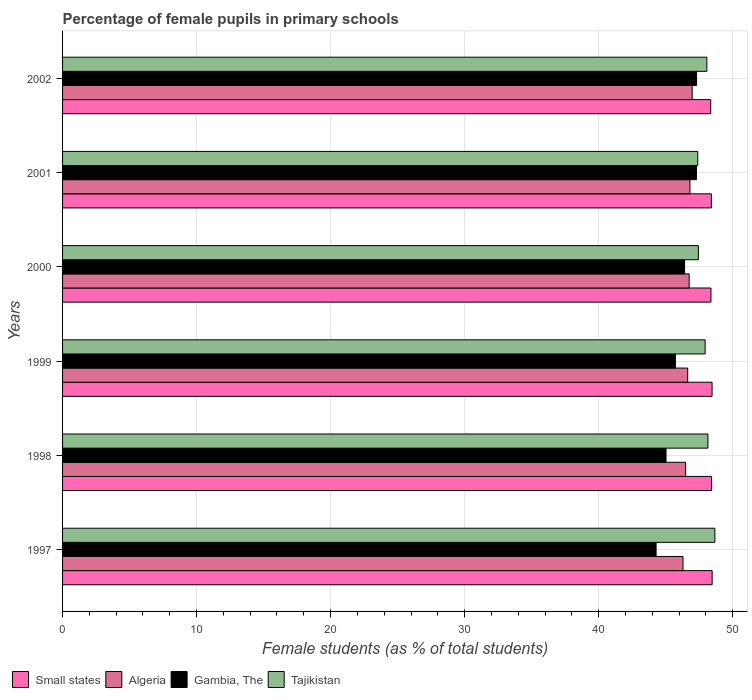Are the number of bars on each tick of the Y-axis equal?
Offer a very short reply. Yes. What is the label of the 1st group of bars from the top?
Your answer should be very brief. 2002. In how many cases, is the number of bars for a given year not equal to the number of legend labels?
Your answer should be very brief. 0. What is the percentage of female pupils in primary schools in Gambia, The in 2002?
Offer a terse response. 47.31. Across all years, what is the maximum percentage of female pupils in primary schools in Small states?
Make the answer very short. 48.47. Across all years, what is the minimum percentage of female pupils in primary schools in Small states?
Offer a terse response. 48.37. What is the total percentage of female pupils in primary schools in Gambia, The in the graph?
Your response must be concise. 276.08. What is the difference between the percentage of female pupils in primary schools in Small states in 1998 and that in 2001?
Offer a terse response. 0.02. What is the difference between the percentage of female pupils in primary schools in Tajikistan in 2000 and the percentage of female pupils in primary schools in Algeria in 1997?
Keep it short and to the point. 1.15. What is the average percentage of female pupils in primary schools in Gambia, The per year?
Your answer should be compact. 46.01. In the year 1998, what is the difference between the percentage of female pupils in primary schools in Small states and percentage of female pupils in primary schools in Tajikistan?
Your response must be concise. 0.27. What is the ratio of the percentage of female pupils in primary schools in Algeria in 1999 to that in 2000?
Offer a very short reply. 1. Is the percentage of female pupils in primary schools in Tajikistan in 1998 less than that in 1999?
Your answer should be compact. No. What is the difference between the highest and the second highest percentage of female pupils in primary schools in Small states?
Your answer should be very brief. 0.01. What is the difference between the highest and the lowest percentage of female pupils in primary schools in Tajikistan?
Provide a short and direct response. 1.28. What does the 2nd bar from the top in 1998 represents?
Give a very brief answer. Gambia, The. What does the 2nd bar from the bottom in 2000 represents?
Provide a succinct answer. Algeria. Is it the case that in every year, the sum of the percentage of female pupils in primary schools in Algeria and percentage of female pupils in primary schools in Tajikistan is greater than the percentage of female pupils in primary schools in Small states?
Offer a very short reply. Yes. Are all the bars in the graph horizontal?
Provide a succinct answer. Yes. How many years are there in the graph?
Offer a very short reply. 6. Are the values on the major ticks of X-axis written in scientific E-notation?
Provide a succinct answer. No. How many legend labels are there?
Provide a succinct answer. 4. How are the legend labels stacked?
Provide a succinct answer. Horizontal. What is the title of the graph?
Ensure brevity in your answer.  Percentage of female pupils in primary schools. What is the label or title of the X-axis?
Provide a short and direct response. Female students (as % of total students). What is the label or title of the Y-axis?
Your answer should be very brief. Years. What is the Female students (as % of total students) in Small states in 1997?
Offer a terse response. 48.47. What is the Female students (as % of total students) in Algeria in 1997?
Make the answer very short. 46.3. What is the Female students (as % of total students) of Gambia, The in 1997?
Offer a terse response. 44.29. What is the Female students (as % of total students) in Tajikistan in 1997?
Your answer should be compact. 48.68. What is the Female students (as % of total students) of Small states in 1998?
Provide a short and direct response. 48.43. What is the Female students (as % of total students) in Algeria in 1998?
Offer a very short reply. 46.49. What is the Female students (as % of total students) of Gambia, The in 1998?
Provide a short and direct response. 45.03. What is the Female students (as % of total students) of Tajikistan in 1998?
Offer a very short reply. 48.16. What is the Female students (as % of total students) of Small states in 1999?
Offer a very short reply. 48.47. What is the Female students (as % of total students) in Algeria in 1999?
Offer a very short reply. 46.65. What is the Female students (as % of total students) of Gambia, The in 1999?
Make the answer very short. 45.73. What is the Female students (as % of total students) of Tajikistan in 1999?
Give a very brief answer. 47.95. What is the Female students (as % of total students) of Small states in 2000?
Your answer should be compact. 48.38. What is the Female students (as % of total students) of Algeria in 2000?
Your answer should be compact. 46.76. What is the Female students (as % of total students) in Gambia, The in 2000?
Provide a succinct answer. 46.42. What is the Female students (as % of total students) of Tajikistan in 2000?
Your answer should be very brief. 47.44. What is the Female students (as % of total students) in Small states in 2001?
Your response must be concise. 48.41. What is the Female students (as % of total students) of Algeria in 2001?
Provide a short and direct response. 46.82. What is the Female students (as % of total students) in Gambia, The in 2001?
Your answer should be compact. 47.3. What is the Female students (as % of total students) of Tajikistan in 2001?
Provide a short and direct response. 47.4. What is the Female students (as % of total students) of Small states in 2002?
Provide a short and direct response. 48.37. What is the Female students (as % of total students) of Algeria in 2002?
Give a very brief answer. 46.98. What is the Female students (as % of total students) in Gambia, The in 2002?
Make the answer very short. 47.31. What is the Female students (as % of total students) in Tajikistan in 2002?
Make the answer very short. 48.08. Across all years, what is the maximum Female students (as % of total students) in Small states?
Provide a short and direct response. 48.47. Across all years, what is the maximum Female students (as % of total students) in Algeria?
Make the answer very short. 46.98. Across all years, what is the maximum Female students (as % of total students) in Gambia, The?
Ensure brevity in your answer.  47.31. Across all years, what is the maximum Female students (as % of total students) of Tajikistan?
Your answer should be compact. 48.68. Across all years, what is the minimum Female students (as % of total students) of Small states?
Keep it short and to the point. 48.37. Across all years, what is the minimum Female students (as % of total students) of Algeria?
Offer a very short reply. 46.3. Across all years, what is the minimum Female students (as % of total students) of Gambia, The?
Provide a succinct answer. 44.29. Across all years, what is the minimum Female students (as % of total students) in Tajikistan?
Ensure brevity in your answer.  47.4. What is the total Female students (as % of total students) in Small states in the graph?
Provide a short and direct response. 290.53. What is the total Female students (as % of total students) in Algeria in the graph?
Keep it short and to the point. 279.99. What is the total Female students (as % of total students) in Gambia, The in the graph?
Give a very brief answer. 276.08. What is the total Female students (as % of total students) in Tajikistan in the graph?
Make the answer very short. 287.7. What is the difference between the Female students (as % of total students) in Algeria in 1997 and that in 1998?
Provide a short and direct response. -0.2. What is the difference between the Female students (as % of total students) in Gambia, The in 1997 and that in 1998?
Your answer should be compact. -0.74. What is the difference between the Female students (as % of total students) of Tajikistan in 1997 and that in 1998?
Provide a short and direct response. 0.52. What is the difference between the Female students (as % of total students) of Small states in 1997 and that in 1999?
Your answer should be compact. 0.01. What is the difference between the Female students (as % of total students) in Algeria in 1997 and that in 1999?
Offer a terse response. -0.35. What is the difference between the Female students (as % of total students) in Gambia, The in 1997 and that in 1999?
Offer a very short reply. -1.44. What is the difference between the Female students (as % of total students) of Tajikistan in 1997 and that in 1999?
Your answer should be compact. 0.73. What is the difference between the Female students (as % of total students) of Small states in 1997 and that in 2000?
Keep it short and to the point. 0.09. What is the difference between the Female students (as % of total students) of Algeria in 1997 and that in 2000?
Offer a terse response. -0.46. What is the difference between the Female students (as % of total students) in Gambia, The in 1997 and that in 2000?
Give a very brief answer. -2.13. What is the difference between the Female students (as % of total students) in Tajikistan in 1997 and that in 2000?
Provide a succinct answer. 1.23. What is the difference between the Female students (as % of total students) in Small states in 1997 and that in 2001?
Give a very brief answer. 0.06. What is the difference between the Female students (as % of total students) in Algeria in 1997 and that in 2001?
Your answer should be compact. -0.52. What is the difference between the Female students (as % of total students) of Gambia, The in 1997 and that in 2001?
Provide a succinct answer. -3.01. What is the difference between the Female students (as % of total students) in Tajikistan in 1997 and that in 2001?
Provide a succinct answer. 1.28. What is the difference between the Female students (as % of total students) of Small states in 1997 and that in 2002?
Offer a very short reply. 0.11. What is the difference between the Female students (as % of total students) in Algeria in 1997 and that in 2002?
Offer a terse response. -0.69. What is the difference between the Female students (as % of total students) in Gambia, The in 1997 and that in 2002?
Offer a terse response. -3.02. What is the difference between the Female students (as % of total students) in Tajikistan in 1997 and that in 2002?
Keep it short and to the point. 0.6. What is the difference between the Female students (as % of total students) of Small states in 1998 and that in 1999?
Give a very brief answer. -0.03. What is the difference between the Female students (as % of total students) in Algeria in 1998 and that in 1999?
Your answer should be compact. -0.15. What is the difference between the Female students (as % of total students) of Gambia, The in 1998 and that in 1999?
Provide a succinct answer. -0.7. What is the difference between the Female students (as % of total students) of Tajikistan in 1998 and that in 1999?
Your answer should be very brief. 0.21. What is the difference between the Female students (as % of total students) of Small states in 1998 and that in 2000?
Make the answer very short. 0.05. What is the difference between the Female students (as % of total students) in Algeria in 1998 and that in 2000?
Your answer should be very brief. -0.27. What is the difference between the Female students (as % of total students) in Gambia, The in 1998 and that in 2000?
Offer a very short reply. -1.39. What is the difference between the Female students (as % of total students) of Tajikistan in 1998 and that in 2000?
Offer a very short reply. 0.72. What is the difference between the Female students (as % of total students) in Small states in 1998 and that in 2001?
Offer a terse response. 0.02. What is the difference between the Female students (as % of total students) of Algeria in 1998 and that in 2001?
Your answer should be very brief. -0.32. What is the difference between the Female students (as % of total students) in Gambia, The in 1998 and that in 2001?
Your response must be concise. -2.27. What is the difference between the Female students (as % of total students) of Tajikistan in 1998 and that in 2001?
Give a very brief answer. 0.76. What is the difference between the Female students (as % of total students) in Small states in 1998 and that in 2002?
Provide a succinct answer. 0.07. What is the difference between the Female students (as % of total students) in Algeria in 1998 and that in 2002?
Give a very brief answer. -0.49. What is the difference between the Female students (as % of total students) of Gambia, The in 1998 and that in 2002?
Provide a succinct answer. -2.28. What is the difference between the Female students (as % of total students) of Tajikistan in 1998 and that in 2002?
Your answer should be compact. 0.08. What is the difference between the Female students (as % of total students) of Small states in 1999 and that in 2000?
Offer a very short reply. 0.08. What is the difference between the Female students (as % of total students) in Algeria in 1999 and that in 2000?
Offer a terse response. -0.11. What is the difference between the Female students (as % of total students) in Gambia, The in 1999 and that in 2000?
Make the answer very short. -0.69. What is the difference between the Female students (as % of total students) in Tajikistan in 1999 and that in 2000?
Your response must be concise. 0.51. What is the difference between the Female students (as % of total students) in Small states in 1999 and that in 2001?
Your answer should be compact. 0.05. What is the difference between the Female students (as % of total students) in Algeria in 1999 and that in 2001?
Provide a short and direct response. -0.17. What is the difference between the Female students (as % of total students) of Gambia, The in 1999 and that in 2001?
Your answer should be very brief. -1.57. What is the difference between the Female students (as % of total students) of Tajikistan in 1999 and that in 2001?
Your response must be concise. 0.55. What is the difference between the Female students (as % of total students) of Small states in 1999 and that in 2002?
Give a very brief answer. 0.1. What is the difference between the Female students (as % of total students) in Algeria in 1999 and that in 2002?
Make the answer very short. -0.34. What is the difference between the Female students (as % of total students) of Gambia, The in 1999 and that in 2002?
Provide a short and direct response. -1.58. What is the difference between the Female students (as % of total students) in Tajikistan in 1999 and that in 2002?
Ensure brevity in your answer.  -0.13. What is the difference between the Female students (as % of total students) in Small states in 2000 and that in 2001?
Provide a short and direct response. -0.03. What is the difference between the Female students (as % of total students) in Algeria in 2000 and that in 2001?
Give a very brief answer. -0.06. What is the difference between the Female students (as % of total students) in Gambia, The in 2000 and that in 2001?
Make the answer very short. -0.88. What is the difference between the Female students (as % of total students) in Tajikistan in 2000 and that in 2001?
Make the answer very short. 0.05. What is the difference between the Female students (as % of total students) in Small states in 2000 and that in 2002?
Give a very brief answer. 0.02. What is the difference between the Female students (as % of total students) of Algeria in 2000 and that in 2002?
Your answer should be compact. -0.23. What is the difference between the Female students (as % of total students) in Gambia, The in 2000 and that in 2002?
Offer a very short reply. -0.89. What is the difference between the Female students (as % of total students) of Tajikistan in 2000 and that in 2002?
Offer a very short reply. -0.63. What is the difference between the Female students (as % of total students) in Small states in 2001 and that in 2002?
Provide a short and direct response. 0.05. What is the difference between the Female students (as % of total students) in Algeria in 2001 and that in 2002?
Offer a terse response. -0.17. What is the difference between the Female students (as % of total students) in Gambia, The in 2001 and that in 2002?
Offer a terse response. -0.01. What is the difference between the Female students (as % of total students) in Tajikistan in 2001 and that in 2002?
Your answer should be compact. -0.68. What is the difference between the Female students (as % of total students) in Small states in 1997 and the Female students (as % of total students) in Algeria in 1998?
Offer a very short reply. 1.98. What is the difference between the Female students (as % of total students) in Small states in 1997 and the Female students (as % of total students) in Gambia, The in 1998?
Your answer should be compact. 3.44. What is the difference between the Female students (as % of total students) of Small states in 1997 and the Female students (as % of total students) of Tajikistan in 1998?
Ensure brevity in your answer.  0.31. What is the difference between the Female students (as % of total students) in Algeria in 1997 and the Female students (as % of total students) in Gambia, The in 1998?
Your answer should be compact. 1.27. What is the difference between the Female students (as % of total students) of Algeria in 1997 and the Female students (as % of total students) of Tajikistan in 1998?
Offer a very short reply. -1.86. What is the difference between the Female students (as % of total students) of Gambia, The in 1997 and the Female students (as % of total students) of Tajikistan in 1998?
Make the answer very short. -3.87. What is the difference between the Female students (as % of total students) of Small states in 1997 and the Female students (as % of total students) of Algeria in 1999?
Offer a terse response. 1.83. What is the difference between the Female students (as % of total students) in Small states in 1997 and the Female students (as % of total students) in Gambia, The in 1999?
Provide a succinct answer. 2.74. What is the difference between the Female students (as % of total students) in Small states in 1997 and the Female students (as % of total students) in Tajikistan in 1999?
Provide a short and direct response. 0.52. What is the difference between the Female students (as % of total students) of Algeria in 1997 and the Female students (as % of total students) of Gambia, The in 1999?
Make the answer very short. 0.57. What is the difference between the Female students (as % of total students) of Algeria in 1997 and the Female students (as % of total students) of Tajikistan in 1999?
Make the answer very short. -1.65. What is the difference between the Female students (as % of total students) in Gambia, The in 1997 and the Female students (as % of total students) in Tajikistan in 1999?
Offer a terse response. -3.66. What is the difference between the Female students (as % of total students) of Small states in 1997 and the Female students (as % of total students) of Algeria in 2000?
Your answer should be very brief. 1.71. What is the difference between the Female students (as % of total students) of Small states in 1997 and the Female students (as % of total students) of Gambia, The in 2000?
Provide a short and direct response. 2.05. What is the difference between the Female students (as % of total students) of Small states in 1997 and the Female students (as % of total students) of Tajikistan in 2000?
Offer a very short reply. 1.03. What is the difference between the Female students (as % of total students) in Algeria in 1997 and the Female students (as % of total students) in Gambia, The in 2000?
Ensure brevity in your answer.  -0.12. What is the difference between the Female students (as % of total students) of Algeria in 1997 and the Female students (as % of total students) of Tajikistan in 2000?
Offer a terse response. -1.15. What is the difference between the Female students (as % of total students) in Gambia, The in 1997 and the Female students (as % of total students) in Tajikistan in 2000?
Offer a very short reply. -3.15. What is the difference between the Female students (as % of total students) in Small states in 1997 and the Female students (as % of total students) in Algeria in 2001?
Make the answer very short. 1.66. What is the difference between the Female students (as % of total students) of Small states in 1997 and the Female students (as % of total students) of Gambia, The in 2001?
Ensure brevity in your answer.  1.17. What is the difference between the Female students (as % of total students) in Small states in 1997 and the Female students (as % of total students) in Tajikistan in 2001?
Make the answer very short. 1.07. What is the difference between the Female students (as % of total students) in Algeria in 1997 and the Female students (as % of total students) in Gambia, The in 2001?
Make the answer very short. -1. What is the difference between the Female students (as % of total students) of Algeria in 1997 and the Female students (as % of total students) of Tajikistan in 2001?
Your answer should be very brief. -1.1. What is the difference between the Female students (as % of total students) in Gambia, The in 1997 and the Female students (as % of total students) in Tajikistan in 2001?
Provide a succinct answer. -3.11. What is the difference between the Female students (as % of total students) of Small states in 1997 and the Female students (as % of total students) of Algeria in 2002?
Your answer should be very brief. 1.49. What is the difference between the Female students (as % of total students) of Small states in 1997 and the Female students (as % of total students) of Gambia, The in 2002?
Offer a terse response. 1.16. What is the difference between the Female students (as % of total students) of Small states in 1997 and the Female students (as % of total students) of Tajikistan in 2002?
Your answer should be compact. 0.4. What is the difference between the Female students (as % of total students) of Algeria in 1997 and the Female students (as % of total students) of Gambia, The in 2002?
Offer a very short reply. -1.02. What is the difference between the Female students (as % of total students) of Algeria in 1997 and the Female students (as % of total students) of Tajikistan in 2002?
Ensure brevity in your answer.  -1.78. What is the difference between the Female students (as % of total students) of Gambia, The in 1997 and the Female students (as % of total students) of Tajikistan in 2002?
Keep it short and to the point. -3.79. What is the difference between the Female students (as % of total students) in Small states in 1998 and the Female students (as % of total students) in Algeria in 1999?
Your response must be concise. 1.79. What is the difference between the Female students (as % of total students) in Small states in 1998 and the Female students (as % of total students) in Gambia, The in 1999?
Your answer should be compact. 2.7. What is the difference between the Female students (as % of total students) in Small states in 1998 and the Female students (as % of total students) in Tajikistan in 1999?
Give a very brief answer. 0.48. What is the difference between the Female students (as % of total students) of Algeria in 1998 and the Female students (as % of total students) of Gambia, The in 1999?
Provide a short and direct response. 0.76. What is the difference between the Female students (as % of total students) in Algeria in 1998 and the Female students (as % of total students) in Tajikistan in 1999?
Offer a very short reply. -1.46. What is the difference between the Female students (as % of total students) in Gambia, The in 1998 and the Female students (as % of total students) in Tajikistan in 1999?
Your response must be concise. -2.92. What is the difference between the Female students (as % of total students) of Small states in 1998 and the Female students (as % of total students) of Algeria in 2000?
Keep it short and to the point. 1.67. What is the difference between the Female students (as % of total students) of Small states in 1998 and the Female students (as % of total students) of Gambia, The in 2000?
Provide a short and direct response. 2.01. What is the difference between the Female students (as % of total students) of Small states in 1998 and the Female students (as % of total students) of Tajikistan in 2000?
Offer a terse response. 0.99. What is the difference between the Female students (as % of total students) in Algeria in 1998 and the Female students (as % of total students) in Gambia, The in 2000?
Provide a succinct answer. 0.07. What is the difference between the Female students (as % of total students) in Algeria in 1998 and the Female students (as % of total students) in Tajikistan in 2000?
Offer a terse response. -0.95. What is the difference between the Female students (as % of total students) of Gambia, The in 1998 and the Female students (as % of total students) of Tajikistan in 2000?
Give a very brief answer. -2.41. What is the difference between the Female students (as % of total students) in Small states in 1998 and the Female students (as % of total students) in Algeria in 2001?
Give a very brief answer. 1.62. What is the difference between the Female students (as % of total students) in Small states in 1998 and the Female students (as % of total students) in Gambia, The in 2001?
Give a very brief answer. 1.13. What is the difference between the Female students (as % of total students) of Small states in 1998 and the Female students (as % of total students) of Tajikistan in 2001?
Ensure brevity in your answer.  1.03. What is the difference between the Female students (as % of total students) in Algeria in 1998 and the Female students (as % of total students) in Gambia, The in 2001?
Provide a short and direct response. -0.81. What is the difference between the Female students (as % of total students) of Algeria in 1998 and the Female students (as % of total students) of Tajikistan in 2001?
Make the answer very short. -0.91. What is the difference between the Female students (as % of total students) of Gambia, The in 1998 and the Female students (as % of total students) of Tajikistan in 2001?
Give a very brief answer. -2.37. What is the difference between the Female students (as % of total students) of Small states in 1998 and the Female students (as % of total students) of Algeria in 2002?
Offer a terse response. 1.45. What is the difference between the Female students (as % of total students) in Small states in 1998 and the Female students (as % of total students) in Gambia, The in 2002?
Offer a terse response. 1.12. What is the difference between the Female students (as % of total students) of Small states in 1998 and the Female students (as % of total students) of Tajikistan in 2002?
Ensure brevity in your answer.  0.36. What is the difference between the Female students (as % of total students) of Algeria in 1998 and the Female students (as % of total students) of Gambia, The in 2002?
Give a very brief answer. -0.82. What is the difference between the Female students (as % of total students) of Algeria in 1998 and the Female students (as % of total students) of Tajikistan in 2002?
Offer a very short reply. -1.58. What is the difference between the Female students (as % of total students) of Gambia, The in 1998 and the Female students (as % of total students) of Tajikistan in 2002?
Your response must be concise. -3.05. What is the difference between the Female students (as % of total students) of Small states in 1999 and the Female students (as % of total students) of Algeria in 2000?
Give a very brief answer. 1.71. What is the difference between the Female students (as % of total students) in Small states in 1999 and the Female students (as % of total students) in Gambia, The in 2000?
Keep it short and to the point. 2.05. What is the difference between the Female students (as % of total students) of Small states in 1999 and the Female students (as % of total students) of Tajikistan in 2000?
Your answer should be compact. 1.02. What is the difference between the Female students (as % of total students) in Algeria in 1999 and the Female students (as % of total students) in Gambia, The in 2000?
Your response must be concise. 0.23. What is the difference between the Female students (as % of total students) of Algeria in 1999 and the Female students (as % of total students) of Tajikistan in 2000?
Give a very brief answer. -0.8. What is the difference between the Female students (as % of total students) of Gambia, The in 1999 and the Female students (as % of total students) of Tajikistan in 2000?
Your answer should be very brief. -1.71. What is the difference between the Female students (as % of total students) of Small states in 1999 and the Female students (as % of total students) of Algeria in 2001?
Offer a terse response. 1.65. What is the difference between the Female students (as % of total students) in Small states in 1999 and the Female students (as % of total students) in Gambia, The in 2001?
Keep it short and to the point. 1.17. What is the difference between the Female students (as % of total students) of Small states in 1999 and the Female students (as % of total students) of Tajikistan in 2001?
Your answer should be very brief. 1.07. What is the difference between the Female students (as % of total students) of Algeria in 1999 and the Female students (as % of total students) of Gambia, The in 2001?
Offer a very short reply. -0.65. What is the difference between the Female students (as % of total students) of Algeria in 1999 and the Female students (as % of total students) of Tajikistan in 2001?
Keep it short and to the point. -0.75. What is the difference between the Female students (as % of total students) of Gambia, The in 1999 and the Female students (as % of total students) of Tajikistan in 2001?
Your answer should be very brief. -1.67. What is the difference between the Female students (as % of total students) in Small states in 1999 and the Female students (as % of total students) in Algeria in 2002?
Provide a short and direct response. 1.48. What is the difference between the Female students (as % of total students) of Small states in 1999 and the Female students (as % of total students) of Gambia, The in 2002?
Offer a very short reply. 1.15. What is the difference between the Female students (as % of total students) of Small states in 1999 and the Female students (as % of total students) of Tajikistan in 2002?
Ensure brevity in your answer.  0.39. What is the difference between the Female students (as % of total students) of Algeria in 1999 and the Female students (as % of total students) of Gambia, The in 2002?
Provide a succinct answer. -0.67. What is the difference between the Female students (as % of total students) of Algeria in 1999 and the Female students (as % of total students) of Tajikistan in 2002?
Offer a very short reply. -1.43. What is the difference between the Female students (as % of total students) in Gambia, The in 1999 and the Female students (as % of total students) in Tajikistan in 2002?
Your answer should be very brief. -2.35. What is the difference between the Female students (as % of total students) in Small states in 2000 and the Female students (as % of total students) in Algeria in 2001?
Give a very brief answer. 1.57. What is the difference between the Female students (as % of total students) in Small states in 2000 and the Female students (as % of total students) in Gambia, The in 2001?
Give a very brief answer. 1.08. What is the difference between the Female students (as % of total students) of Small states in 2000 and the Female students (as % of total students) of Tajikistan in 2001?
Offer a terse response. 0.99. What is the difference between the Female students (as % of total students) in Algeria in 2000 and the Female students (as % of total students) in Gambia, The in 2001?
Your answer should be compact. -0.54. What is the difference between the Female students (as % of total students) in Algeria in 2000 and the Female students (as % of total students) in Tajikistan in 2001?
Provide a short and direct response. -0.64. What is the difference between the Female students (as % of total students) of Gambia, The in 2000 and the Female students (as % of total students) of Tajikistan in 2001?
Ensure brevity in your answer.  -0.98. What is the difference between the Female students (as % of total students) in Small states in 2000 and the Female students (as % of total students) in Algeria in 2002?
Give a very brief answer. 1.4. What is the difference between the Female students (as % of total students) of Small states in 2000 and the Female students (as % of total students) of Gambia, The in 2002?
Offer a very short reply. 1.07. What is the difference between the Female students (as % of total students) in Small states in 2000 and the Female students (as % of total students) in Tajikistan in 2002?
Your answer should be compact. 0.31. What is the difference between the Female students (as % of total students) of Algeria in 2000 and the Female students (as % of total students) of Gambia, The in 2002?
Keep it short and to the point. -0.55. What is the difference between the Female students (as % of total students) of Algeria in 2000 and the Female students (as % of total students) of Tajikistan in 2002?
Keep it short and to the point. -1.32. What is the difference between the Female students (as % of total students) in Gambia, The in 2000 and the Female students (as % of total students) in Tajikistan in 2002?
Your response must be concise. -1.66. What is the difference between the Female students (as % of total students) of Small states in 2001 and the Female students (as % of total students) of Algeria in 2002?
Your answer should be very brief. 1.43. What is the difference between the Female students (as % of total students) of Small states in 2001 and the Female students (as % of total students) of Gambia, The in 2002?
Make the answer very short. 1.1. What is the difference between the Female students (as % of total students) in Small states in 2001 and the Female students (as % of total students) in Tajikistan in 2002?
Provide a succinct answer. 0.34. What is the difference between the Female students (as % of total students) of Algeria in 2001 and the Female students (as % of total students) of Gambia, The in 2002?
Your answer should be compact. -0.5. What is the difference between the Female students (as % of total students) of Algeria in 2001 and the Female students (as % of total students) of Tajikistan in 2002?
Your response must be concise. -1.26. What is the difference between the Female students (as % of total students) in Gambia, The in 2001 and the Female students (as % of total students) in Tajikistan in 2002?
Your answer should be very brief. -0.78. What is the average Female students (as % of total students) in Small states per year?
Your answer should be compact. 48.42. What is the average Female students (as % of total students) of Algeria per year?
Provide a succinct answer. 46.66. What is the average Female students (as % of total students) in Gambia, The per year?
Provide a succinct answer. 46.01. What is the average Female students (as % of total students) in Tajikistan per year?
Offer a very short reply. 47.95. In the year 1997, what is the difference between the Female students (as % of total students) of Small states and Female students (as % of total students) of Algeria?
Your response must be concise. 2.18. In the year 1997, what is the difference between the Female students (as % of total students) in Small states and Female students (as % of total students) in Gambia, The?
Your answer should be very brief. 4.18. In the year 1997, what is the difference between the Female students (as % of total students) of Small states and Female students (as % of total students) of Tajikistan?
Offer a terse response. -0.2. In the year 1997, what is the difference between the Female students (as % of total students) of Algeria and Female students (as % of total students) of Gambia, The?
Your answer should be very brief. 2.01. In the year 1997, what is the difference between the Female students (as % of total students) in Algeria and Female students (as % of total students) in Tajikistan?
Provide a short and direct response. -2.38. In the year 1997, what is the difference between the Female students (as % of total students) of Gambia, The and Female students (as % of total students) of Tajikistan?
Give a very brief answer. -4.39. In the year 1998, what is the difference between the Female students (as % of total students) of Small states and Female students (as % of total students) of Algeria?
Your answer should be compact. 1.94. In the year 1998, what is the difference between the Female students (as % of total students) of Small states and Female students (as % of total students) of Gambia, The?
Keep it short and to the point. 3.4. In the year 1998, what is the difference between the Female students (as % of total students) of Small states and Female students (as % of total students) of Tajikistan?
Your answer should be very brief. 0.27. In the year 1998, what is the difference between the Female students (as % of total students) in Algeria and Female students (as % of total students) in Gambia, The?
Your answer should be very brief. 1.46. In the year 1998, what is the difference between the Female students (as % of total students) in Algeria and Female students (as % of total students) in Tajikistan?
Keep it short and to the point. -1.67. In the year 1998, what is the difference between the Female students (as % of total students) of Gambia, The and Female students (as % of total students) of Tajikistan?
Your answer should be very brief. -3.13. In the year 1999, what is the difference between the Female students (as % of total students) in Small states and Female students (as % of total students) in Algeria?
Make the answer very short. 1.82. In the year 1999, what is the difference between the Female students (as % of total students) of Small states and Female students (as % of total students) of Gambia, The?
Offer a very short reply. 2.74. In the year 1999, what is the difference between the Female students (as % of total students) in Small states and Female students (as % of total students) in Tajikistan?
Offer a terse response. 0.52. In the year 1999, what is the difference between the Female students (as % of total students) in Algeria and Female students (as % of total students) in Gambia, The?
Your answer should be very brief. 0.92. In the year 1999, what is the difference between the Female students (as % of total students) of Algeria and Female students (as % of total students) of Tajikistan?
Keep it short and to the point. -1.3. In the year 1999, what is the difference between the Female students (as % of total students) of Gambia, The and Female students (as % of total students) of Tajikistan?
Give a very brief answer. -2.22. In the year 2000, what is the difference between the Female students (as % of total students) of Small states and Female students (as % of total students) of Algeria?
Provide a succinct answer. 1.63. In the year 2000, what is the difference between the Female students (as % of total students) in Small states and Female students (as % of total students) in Gambia, The?
Keep it short and to the point. 1.97. In the year 2000, what is the difference between the Female students (as % of total students) of Small states and Female students (as % of total students) of Tajikistan?
Ensure brevity in your answer.  0.94. In the year 2000, what is the difference between the Female students (as % of total students) of Algeria and Female students (as % of total students) of Gambia, The?
Offer a very short reply. 0.34. In the year 2000, what is the difference between the Female students (as % of total students) in Algeria and Female students (as % of total students) in Tajikistan?
Your answer should be very brief. -0.68. In the year 2000, what is the difference between the Female students (as % of total students) of Gambia, The and Female students (as % of total students) of Tajikistan?
Your answer should be compact. -1.03. In the year 2001, what is the difference between the Female students (as % of total students) in Small states and Female students (as % of total students) in Algeria?
Provide a succinct answer. 1.6. In the year 2001, what is the difference between the Female students (as % of total students) of Small states and Female students (as % of total students) of Gambia, The?
Keep it short and to the point. 1.11. In the year 2001, what is the difference between the Female students (as % of total students) in Small states and Female students (as % of total students) in Tajikistan?
Offer a terse response. 1.02. In the year 2001, what is the difference between the Female students (as % of total students) of Algeria and Female students (as % of total students) of Gambia, The?
Ensure brevity in your answer.  -0.49. In the year 2001, what is the difference between the Female students (as % of total students) of Algeria and Female students (as % of total students) of Tajikistan?
Offer a very short reply. -0.58. In the year 2001, what is the difference between the Female students (as % of total students) of Gambia, The and Female students (as % of total students) of Tajikistan?
Ensure brevity in your answer.  -0.1. In the year 2002, what is the difference between the Female students (as % of total students) of Small states and Female students (as % of total students) of Algeria?
Your response must be concise. 1.38. In the year 2002, what is the difference between the Female students (as % of total students) of Small states and Female students (as % of total students) of Gambia, The?
Your answer should be compact. 1.05. In the year 2002, what is the difference between the Female students (as % of total students) in Small states and Female students (as % of total students) in Tajikistan?
Your answer should be compact. 0.29. In the year 2002, what is the difference between the Female students (as % of total students) of Algeria and Female students (as % of total students) of Gambia, The?
Offer a very short reply. -0.33. In the year 2002, what is the difference between the Female students (as % of total students) of Algeria and Female students (as % of total students) of Tajikistan?
Give a very brief answer. -1.09. In the year 2002, what is the difference between the Female students (as % of total students) in Gambia, The and Female students (as % of total students) in Tajikistan?
Give a very brief answer. -0.76. What is the ratio of the Female students (as % of total students) in Algeria in 1997 to that in 1998?
Provide a short and direct response. 1. What is the ratio of the Female students (as % of total students) of Gambia, The in 1997 to that in 1998?
Provide a succinct answer. 0.98. What is the ratio of the Female students (as % of total students) of Tajikistan in 1997 to that in 1998?
Offer a terse response. 1.01. What is the ratio of the Female students (as % of total students) in Algeria in 1997 to that in 1999?
Offer a very short reply. 0.99. What is the ratio of the Female students (as % of total students) in Gambia, The in 1997 to that in 1999?
Your answer should be compact. 0.97. What is the ratio of the Female students (as % of total students) in Tajikistan in 1997 to that in 1999?
Keep it short and to the point. 1.02. What is the ratio of the Female students (as % of total students) in Gambia, The in 1997 to that in 2000?
Offer a terse response. 0.95. What is the ratio of the Female students (as % of total students) of Tajikistan in 1997 to that in 2000?
Offer a very short reply. 1.03. What is the ratio of the Female students (as % of total students) of Algeria in 1997 to that in 2001?
Your response must be concise. 0.99. What is the ratio of the Female students (as % of total students) of Gambia, The in 1997 to that in 2001?
Your answer should be very brief. 0.94. What is the ratio of the Female students (as % of total students) of Algeria in 1997 to that in 2002?
Your response must be concise. 0.99. What is the ratio of the Female students (as % of total students) of Gambia, The in 1997 to that in 2002?
Your answer should be very brief. 0.94. What is the ratio of the Female students (as % of total students) in Tajikistan in 1997 to that in 2002?
Your answer should be compact. 1.01. What is the ratio of the Female students (as % of total students) of Small states in 1998 to that in 1999?
Give a very brief answer. 1. What is the ratio of the Female students (as % of total students) of Algeria in 1998 to that in 1999?
Offer a very short reply. 1. What is the ratio of the Female students (as % of total students) in Gambia, The in 1998 to that in 1999?
Your response must be concise. 0.98. What is the ratio of the Female students (as % of total students) in Small states in 1998 to that in 2000?
Make the answer very short. 1. What is the ratio of the Female students (as % of total students) in Gambia, The in 1998 to that in 2000?
Your answer should be compact. 0.97. What is the ratio of the Female students (as % of total students) in Tajikistan in 1998 to that in 2000?
Offer a very short reply. 1.02. What is the ratio of the Female students (as % of total students) of Tajikistan in 1998 to that in 2001?
Your answer should be very brief. 1.02. What is the ratio of the Female students (as % of total students) of Small states in 1998 to that in 2002?
Ensure brevity in your answer.  1. What is the ratio of the Female students (as % of total students) in Algeria in 1998 to that in 2002?
Offer a very short reply. 0.99. What is the ratio of the Female students (as % of total students) in Gambia, The in 1998 to that in 2002?
Offer a terse response. 0.95. What is the ratio of the Female students (as % of total students) in Small states in 1999 to that in 2000?
Offer a terse response. 1. What is the ratio of the Female students (as % of total students) in Gambia, The in 1999 to that in 2000?
Ensure brevity in your answer.  0.99. What is the ratio of the Female students (as % of total students) in Tajikistan in 1999 to that in 2000?
Give a very brief answer. 1.01. What is the ratio of the Female students (as % of total students) in Small states in 1999 to that in 2001?
Give a very brief answer. 1. What is the ratio of the Female students (as % of total students) in Gambia, The in 1999 to that in 2001?
Give a very brief answer. 0.97. What is the ratio of the Female students (as % of total students) of Tajikistan in 1999 to that in 2001?
Your answer should be very brief. 1.01. What is the ratio of the Female students (as % of total students) in Gambia, The in 1999 to that in 2002?
Your answer should be compact. 0.97. What is the ratio of the Female students (as % of total students) in Small states in 2000 to that in 2001?
Provide a short and direct response. 1. What is the ratio of the Female students (as % of total students) in Algeria in 2000 to that in 2001?
Your answer should be very brief. 1. What is the ratio of the Female students (as % of total students) in Gambia, The in 2000 to that in 2001?
Your answer should be very brief. 0.98. What is the ratio of the Female students (as % of total students) of Algeria in 2000 to that in 2002?
Offer a very short reply. 1. What is the ratio of the Female students (as % of total students) of Gambia, The in 2000 to that in 2002?
Provide a succinct answer. 0.98. What is the ratio of the Female students (as % of total students) in Algeria in 2001 to that in 2002?
Provide a short and direct response. 1. What is the ratio of the Female students (as % of total students) of Tajikistan in 2001 to that in 2002?
Make the answer very short. 0.99. What is the difference between the highest and the second highest Female students (as % of total students) in Small states?
Provide a short and direct response. 0.01. What is the difference between the highest and the second highest Female students (as % of total students) in Algeria?
Offer a very short reply. 0.17. What is the difference between the highest and the second highest Female students (as % of total students) in Gambia, The?
Offer a very short reply. 0.01. What is the difference between the highest and the second highest Female students (as % of total students) of Tajikistan?
Offer a very short reply. 0.52. What is the difference between the highest and the lowest Female students (as % of total students) in Small states?
Offer a very short reply. 0.11. What is the difference between the highest and the lowest Female students (as % of total students) of Algeria?
Make the answer very short. 0.69. What is the difference between the highest and the lowest Female students (as % of total students) in Gambia, The?
Your answer should be compact. 3.02. What is the difference between the highest and the lowest Female students (as % of total students) of Tajikistan?
Offer a very short reply. 1.28. 